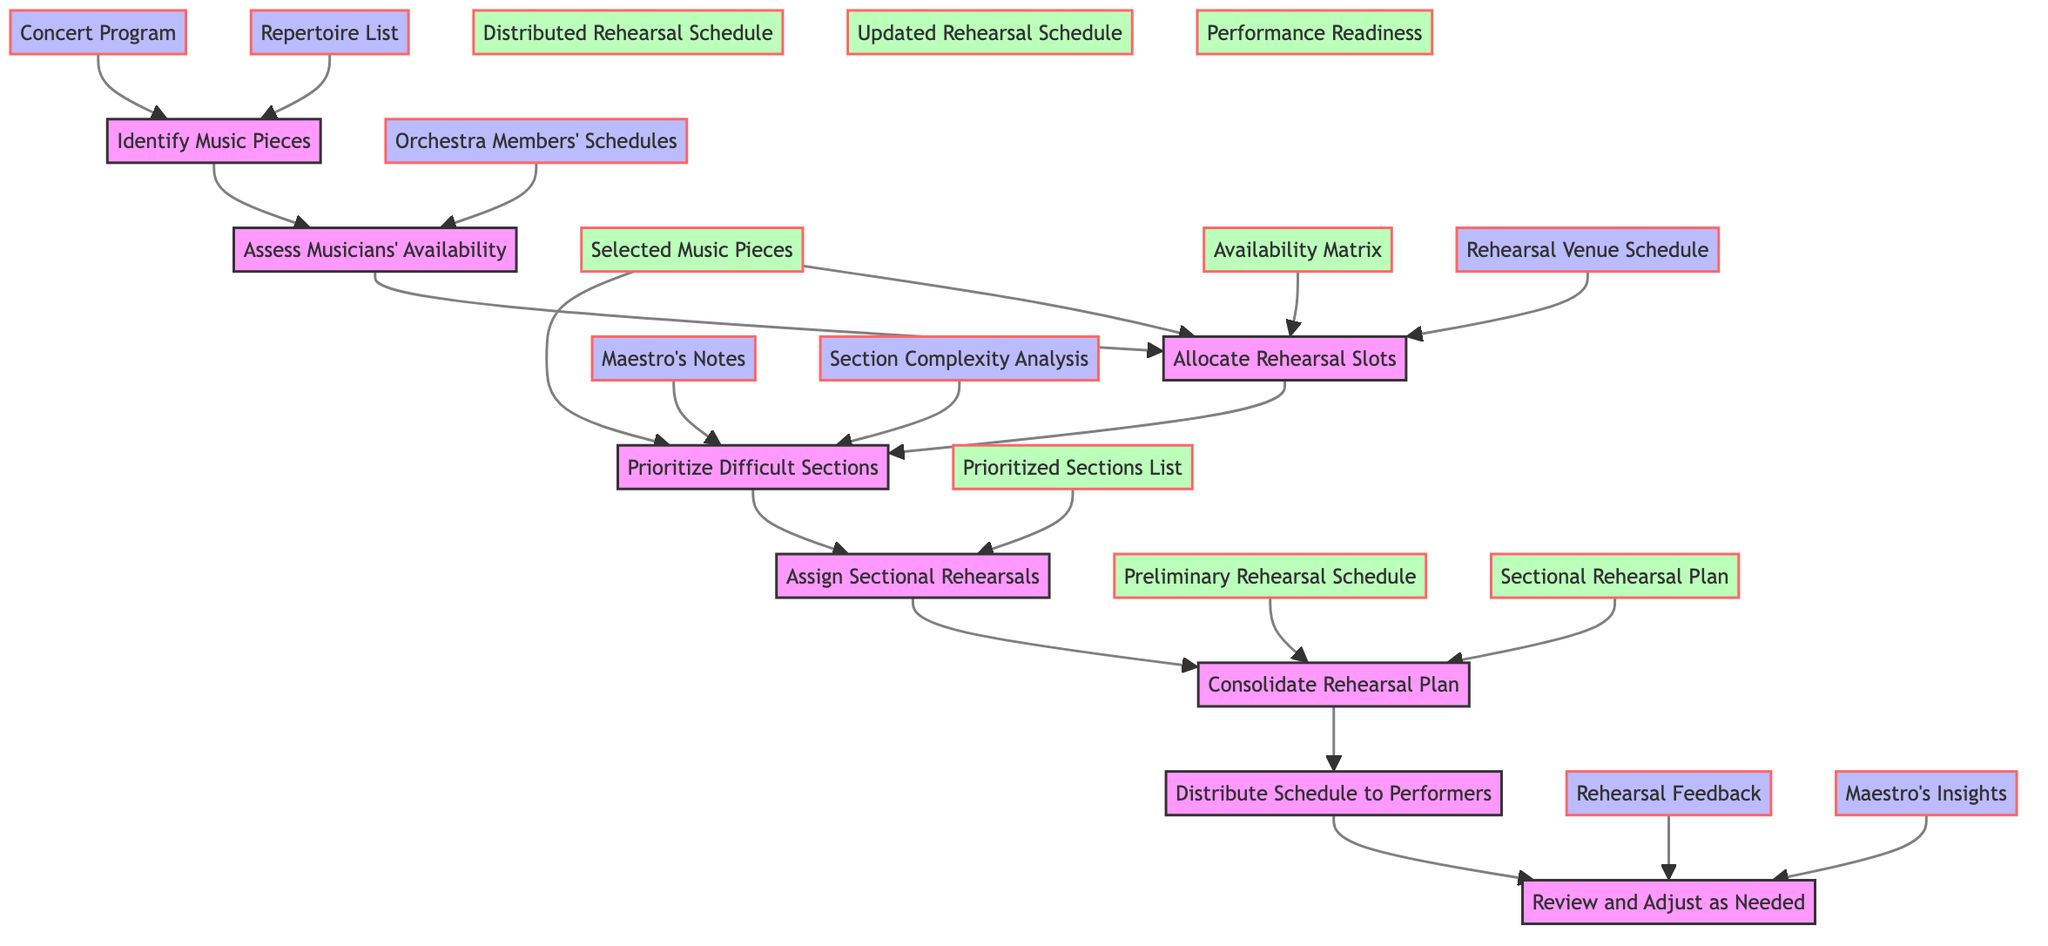What is the first step in the flowchart? The first step is "Identify Music Pieces," which is the initial action taken in the rehearsal scheduling process.
Answer: Identify Music Pieces Which step assesses the musicians' availability? The step titled "Assess Musicians' Availability" is specifically designed to gather data regarding the availability of each musician in the orchestra.
Answer: Assess Musicians' Availability How many total steps are there in the flowchart? The diagram consists of eight distinct steps in total, each representing a phase in the rehearsal scheduling process.
Answer: Eight What is the output of the "Consolidate Rehearsal Plan" step? The output produced by this step is the "Final Rehearsal Schedule," which integrates sectional rehearsals with full orchestra rehearsals.
Answer: Final Rehearsal Schedule What inputs are needed for the "Allocate Rehearsal Slots" step? This step requires three inputs: "Availability Matrix," "Selected Music Pieces," and "Rehearsal Venue Schedule" in order to determine how to allocate rehearsal timings effectively.
Answer: Availability Matrix, Selected Music Pieces, Rehearsal Venue Schedule What is the final output of the flowchart? The flowchart culminates in the "Distributed Rehearsal Schedule," which is the finalized schedule shared with all performers and stakeholders.
Answer: Distributed Rehearsal Schedule What is the connection between the "Review and Adjust as Needed" step and its inputs? This step directly utilizes "Rehearsal Feedback" and "Maestro's Insights" as inputs to continuously refine and update the rehearsal schedule according to progress and observations.
Answer: Rehearsal Feedback, Maestro's Insights Which steps are outputs of the "Review and Adjust as Needed" step? The outputs from this step are the "Updated Rehearsal Schedule" and "Performance Readiness," indicating necessary changes and the preparedness for performance.
Answer: Updated Rehearsal Schedule, Performance Readiness 